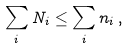<formula> <loc_0><loc_0><loc_500><loc_500>\sum _ { i } N _ { i } \leq \sum _ { i } n _ { i } \, ,</formula> 